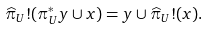<formula> <loc_0><loc_0><loc_500><loc_500>\widehat { \pi } _ { U } ! ( \pi _ { U } ^ { * } y \cup x ) = y \cup \widehat { \pi } _ { U } ! ( x ) .</formula> 